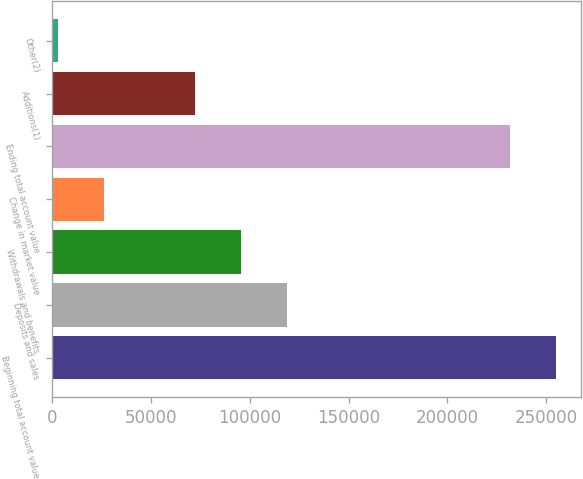Convert chart. <chart><loc_0><loc_0><loc_500><loc_500><bar_chart><fcel>Beginning total account value<fcel>Deposits and sales<fcel>Withdrawals and benefits<fcel>Change in market value<fcel>Ending total account value<fcel>Additions(1)<fcel>Other(2)<nl><fcel>254837<fcel>118776<fcel>95608.6<fcel>26104.9<fcel>231669<fcel>72440.7<fcel>2937<nl></chart> 